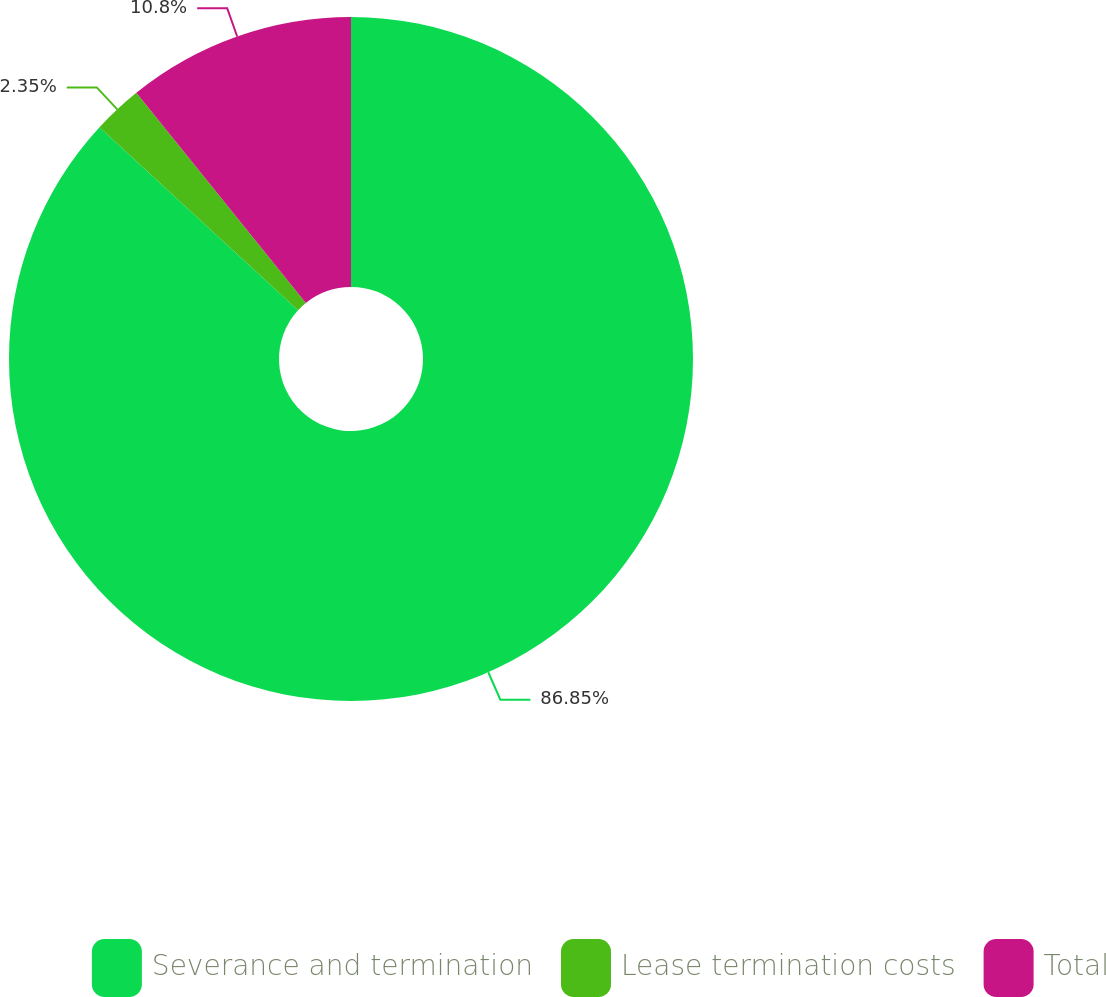Convert chart to OTSL. <chart><loc_0><loc_0><loc_500><loc_500><pie_chart><fcel>Severance and termination<fcel>Lease termination costs<fcel>Total<nl><fcel>86.85%<fcel>2.35%<fcel>10.8%<nl></chart> 